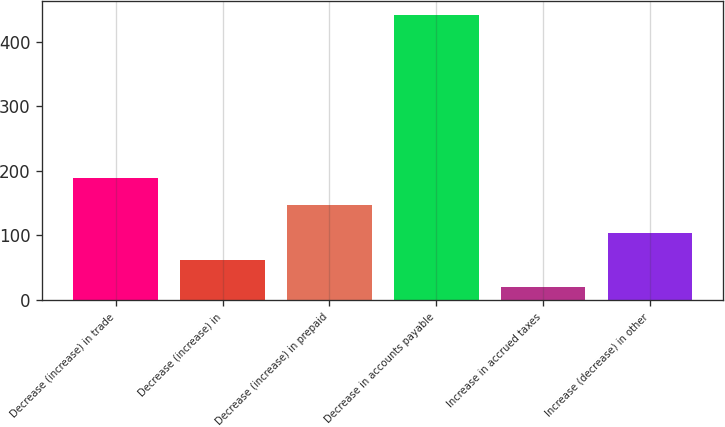<chart> <loc_0><loc_0><loc_500><loc_500><bar_chart><fcel>Decrease (increase) in trade<fcel>Decrease (increase) in<fcel>Decrease (increase) in prepaid<fcel>Decrease in accounts payable<fcel>Increase in accrued taxes<fcel>Increase (decrease) in other<nl><fcel>188.8<fcel>62.2<fcel>146.6<fcel>442<fcel>20<fcel>104.4<nl></chart> 